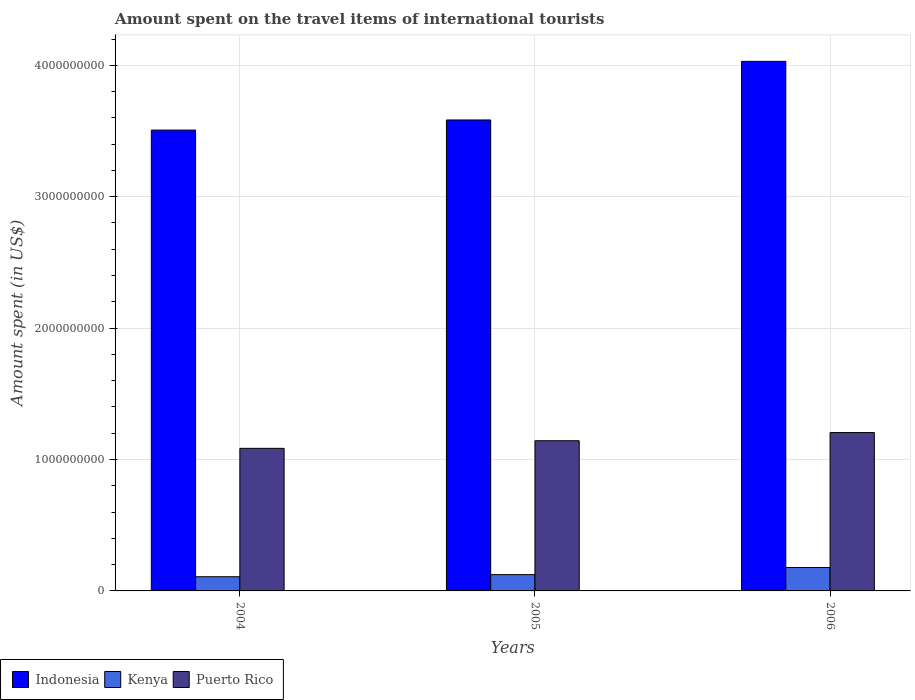How many groups of bars are there?
Your answer should be compact. 3. Are the number of bars on each tick of the X-axis equal?
Your answer should be very brief. Yes. How many bars are there on the 3rd tick from the right?
Offer a very short reply. 3. What is the label of the 3rd group of bars from the left?
Make the answer very short. 2006. What is the amount spent on the travel items of international tourists in Puerto Rico in 2005?
Make the answer very short. 1.14e+09. Across all years, what is the maximum amount spent on the travel items of international tourists in Indonesia?
Make the answer very short. 4.03e+09. Across all years, what is the minimum amount spent on the travel items of international tourists in Indonesia?
Offer a very short reply. 3.51e+09. What is the total amount spent on the travel items of international tourists in Indonesia in the graph?
Provide a short and direct response. 1.11e+1. What is the difference between the amount spent on the travel items of international tourists in Indonesia in 2004 and that in 2006?
Offer a very short reply. -5.23e+08. What is the difference between the amount spent on the travel items of international tourists in Indonesia in 2005 and the amount spent on the travel items of international tourists in Puerto Rico in 2006?
Offer a terse response. 2.38e+09. What is the average amount spent on the travel items of international tourists in Indonesia per year?
Your response must be concise. 3.71e+09. In the year 2005, what is the difference between the amount spent on the travel items of international tourists in Indonesia and amount spent on the travel items of international tourists in Kenya?
Your response must be concise. 3.46e+09. In how many years, is the amount spent on the travel items of international tourists in Puerto Rico greater than 3800000000 US$?
Your response must be concise. 0. What is the ratio of the amount spent on the travel items of international tourists in Puerto Rico in 2004 to that in 2006?
Your answer should be very brief. 0.9. Is the amount spent on the travel items of international tourists in Kenya in 2004 less than that in 2006?
Give a very brief answer. Yes. Is the difference between the amount spent on the travel items of international tourists in Indonesia in 2005 and 2006 greater than the difference between the amount spent on the travel items of international tourists in Kenya in 2005 and 2006?
Your response must be concise. No. What is the difference between the highest and the second highest amount spent on the travel items of international tourists in Puerto Rico?
Ensure brevity in your answer.  6.20e+07. What is the difference between the highest and the lowest amount spent on the travel items of international tourists in Indonesia?
Ensure brevity in your answer.  5.23e+08. Is the sum of the amount spent on the travel items of international tourists in Kenya in 2004 and 2006 greater than the maximum amount spent on the travel items of international tourists in Puerto Rico across all years?
Offer a terse response. No. What does the 2nd bar from the left in 2005 represents?
Provide a short and direct response. Kenya. What does the 2nd bar from the right in 2004 represents?
Make the answer very short. Kenya. Is it the case that in every year, the sum of the amount spent on the travel items of international tourists in Puerto Rico and amount spent on the travel items of international tourists in Indonesia is greater than the amount spent on the travel items of international tourists in Kenya?
Ensure brevity in your answer.  Yes. How many years are there in the graph?
Provide a short and direct response. 3. What is the difference between two consecutive major ticks on the Y-axis?
Your answer should be very brief. 1.00e+09. Does the graph contain any zero values?
Give a very brief answer. No. Where does the legend appear in the graph?
Provide a succinct answer. Bottom left. How many legend labels are there?
Offer a terse response. 3. How are the legend labels stacked?
Provide a short and direct response. Horizontal. What is the title of the graph?
Your answer should be very brief. Amount spent on the travel items of international tourists. What is the label or title of the X-axis?
Offer a terse response. Years. What is the label or title of the Y-axis?
Offer a terse response. Amount spent (in US$). What is the Amount spent (in US$) of Indonesia in 2004?
Provide a short and direct response. 3.51e+09. What is the Amount spent (in US$) in Kenya in 2004?
Offer a very short reply. 1.08e+08. What is the Amount spent (in US$) of Puerto Rico in 2004?
Keep it short and to the point. 1.08e+09. What is the Amount spent (in US$) of Indonesia in 2005?
Offer a very short reply. 3.58e+09. What is the Amount spent (in US$) in Kenya in 2005?
Keep it short and to the point. 1.24e+08. What is the Amount spent (in US$) of Puerto Rico in 2005?
Your answer should be very brief. 1.14e+09. What is the Amount spent (in US$) in Indonesia in 2006?
Offer a very short reply. 4.03e+09. What is the Amount spent (in US$) of Kenya in 2006?
Ensure brevity in your answer.  1.78e+08. What is the Amount spent (in US$) in Puerto Rico in 2006?
Give a very brief answer. 1.20e+09. Across all years, what is the maximum Amount spent (in US$) in Indonesia?
Offer a very short reply. 4.03e+09. Across all years, what is the maximum Amount spent (in US$) of Kenya?
Your answer should be compact. 1.78e+08. Across all years, what is the maximum Amount spent (in US$) of Puerto Rico?
Offer a terse response. 1.20e+09. Across all years, what is the minimum Amount spent (in US$) in Indonesia?
Offer a terse response. 3.51e+09. Across all years, what is the minimum Amount spent (in US$) of Kenya?
Offer a terse response. 1.08e+08. Across all years, what is the minimum Amount spent (in US$) of Puerto Rico?
Offer a terse response. 1.08e+09. What is the total Amount spent (in US$) in Indonesia in the graph?
Provide a succinct answer. 1.11e+1. What is the total Amount spent (in US$) of Kenya in the graph?
Your answer should be very brief. 4.10e+08. What is the total Amount spent (in US$) in Puerto Rico in the graph?
Make the answer very short. 3.43e+09. What is the difference between the Amount spent (in US$) of Indonesia in 2004 and that in 2005?
Give a very brief answer. -7.70e+07. What is the difference between the Amount spent (in US$) in Kenya in 2004 and that in 2005?
Provide a short and direct response. -1.60e+07. What is the difference between the Amount spent (in US$) in Puerto Rico in 2004 and that in 2005?
Your answer should be compact. -5.80e+07. What is the difference between the Amount spent (in US$) in Indonesia in 2004 and that in 2006?
Provide a succinct answer. -5.23e+08. What is the difference between the Amount spent (in US$) of Kenya in 2004 and that in 2006?
Make the answer very short. -7.00e+07. What is the difference between the Amount spent (in US$) of Puerto Rico in 2004 and that in 2006?
Your answer should be very brief. -1.20e+08. What is the difference between the Amount spent (in US$) of Indonesia in 2005 and that in 2006?
Offer a very short reply. -4.46e+08. What is the difference between the Amount spent (in US$) in Kenya in 2005 and that in 2006?
Offer a terse response. -5.40e+07. What is the difference between the Amount spent (in US$) of Puerto Rico in 2005 and that in 2006?
Your answer should be very brief. -6.20e+07. What is the difference between the Amount spent (in US$) of Indonesia in 2004 and the Amount spent (in US$) of Kenya in 2005?
Your answer should be compact. 3.38e+09. What is the difference between the Amount spent (in US$) of Indonesia in 2004 and the Amount spent (in US$) of Puerto Rico in 2005?
Your response must be concise. 2.36e+09. What is the difference between the Amount spent (in US$) in Kenya in 2004 and the Amount spent (in US$) in Puerto Rico in 2005?
Offer a terse response. -1.04e+09. What is the difference between the Amount spent (in US$) of Indonesia in 2004 and the Amount spent (in US$) of Kenya in 2006?
Ensure brevity in your answer.  3.33e+09. What is the difference between the Amount spent (in US$) in Indonesia in 2004 and the Amount spent (in US$) in Puerto Rico in 2006?
Give a very brief answer. 2.30e+09. What is the difference between the Amount spent (in US$) of Kenya in 2004 and the Amount spent (in US$) of Puerto Rico in 2006?
Your answer should be compact. -1.10e+09. What is the difference between the Amount spent (in US$) in Indonesia in 2005 and the Amount spent (in US$) in Kenya in 2006?
Give a very brief answer. 3.41e+09. What is the difference between the Amount spent (in US$) of Indonesia in 2005 and the Amount spent (in US$) of Puerto Rico in 2006?
Offer a very short reply. 2.38e+09. What is the difference between the Amount spent (in US$) in Kenya in 2005 and the Amount spent (in US$) in Puerto Rico in 2006?
Keep it short and to the point. -1.08e+09. What is the average Amount spent (in US$) of Indonesia per year?
Offer a very short reply. 3.71e+09. What is the average Amount spent (in US$) in Kenya per year?
Provide a succinct answer. 1.37e+08. What is the average Amount spent (in US$) in Puerto Rico per year?
Your response must be concise. 1.14e+09. In the year 2004, what is the difference between the Amount spent (in US$) of Indonesia and Amount spent (in US$) of Kenya?
Provide a succinct answer. 3.40e+09. In the year 2004, what is the difference between the Amount spent (in US$) in Indonesia and Amount spent (in US$) in Puerto Rico?
Your answer should be compact. 2.42e+09. In the year 2004, what is the difference between the Amount spent (in US$) of Kenya and Amount spent (in US$) of Puerto Rico?
Offer a terse response. -9.77e+08. In the year 2005, what is the difference between the Amount spent (in US$) in Indonesia and Amount spent (in US$) in Kenya?
Make the answer very short. 3.46e+09. In the year 2005, what is the difference between the Amount spent (in US$) of Indonesia and Amount spent (in US$) of Puerto Rico?
Your answer should be very brief. 2.44e+09. In the year 2005, what is the difference between the Amount spent (in US$) of Kenya and Amount spent (in US$) of Puerto Rico?
Your response must be concise. -1.02e+09. In the year 2006, what is the difference between the Amount spent (in US$) in Indonesia and Amount spent (in US$) in Kenya?
Your answer should be very brief. 3.85e+09. In the year 2006, what is the difference between the Amount spent (in US$) in Indonesia and Amount spent (in US$) in Puerto Rico?
Ensure brevity in your answer.  2.82e+09. In the year 2006, what is the difference between the Amount spent (in US$) in Kenya and Amount spent (in US$) in Puerto Rico?
Provide a succinct answer. -1.03e+09. What is the ratio of the Amount spent (in US$) of Indonesia in 2004 to that in 2005?
Ensure brevity in your answer.  0.98. What is the ratio of the Amount spent (in US$) in Kenya in 2004 to that in 2005?
Offer a very short reply. 0.87. What is the ratio of the Amount spent (in US$) in Puerto Rico in 2004 to that in 2005?
Provide a succinct answer. 0.95. What is the ratio of the Amount spent (in US$) in Indonesia in 2004 to that in 2006?
Provide a succinct answer. 0.87. What is the ratio of the Amount spent (in US$) in Kenya in 2004 to that in 2006?
Your answer should be very brief. 0.61. What is the ratio of the Amount spent (in US$) in Puerto Rico in 2004 to that in 2006?
Offer a very short reply. 0.9. What is the ratio of the Amount spent (in US$) of Indonesia in 2005 to that in 2006?
Give a very brief answer. 0.89. What is the ratio of the Amount spent (in US$) in Kenya in 2005 to that in 2006?
Offer a very short reply. 0.7. What is the ratio of the Amount spent (in US$) in Puerto Rico in 2005 to that in 2006?
Make the answer very short. 0.95. What is the difference between the highest and the second highest Amount spent (in US$) of Indonesia?
Keep it short and to the point. 4.46e+08. What is the difference between the highest and the second highest Amount spent (in US$) of Kenya?
Keep it short and to the point. 5.40e+07. What is the difference between the highest and the second highest Amount spent (in US$) of Puerto Rico?
Your answer should be very brief. 6.20e+07. What is the difference between the highest and the lowest Amount spent (in US$) of Indonesia?
Make the answer very short. 5.23e+08. What is the difference between the highest and the lowest Amount spent (in US$) of Kenya?
Provide a short and direct response. 7.00e+07. What is the difference between the highest and the lowest Amount spent (in US$) of Puerto Rico?
Your answer should be very brief. 1.20e+08. 